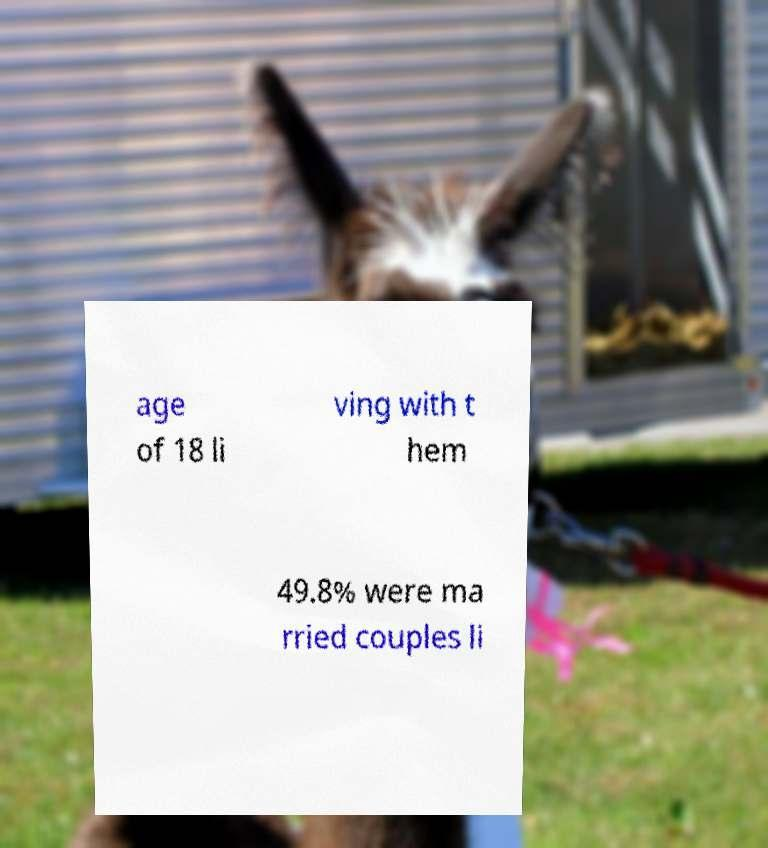There's text embedded in this image that I need extracted. Can you transcribe it verbatim? age of 18 li ving with t hem 49.8% were ma rried couples li 